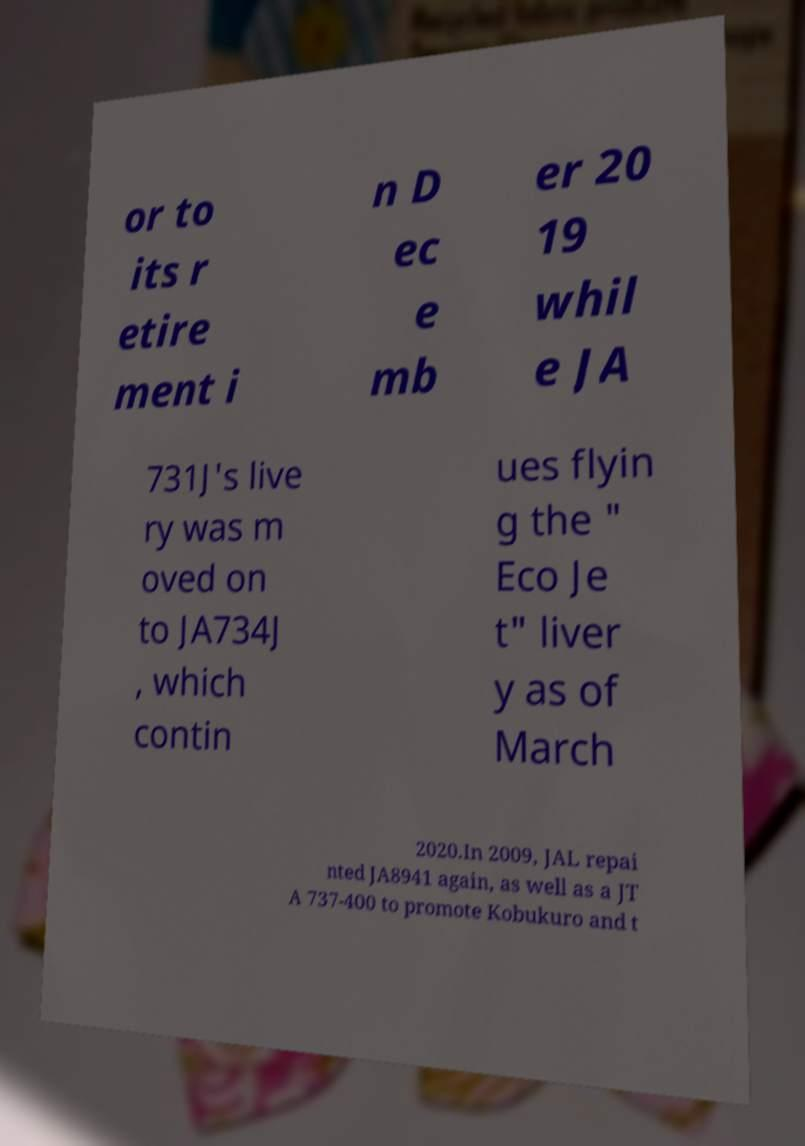There's text embedded in this image that I need extracted. Can you transcribe it verbatim? or to its r etire ment i n D ec e mb er 20 19 whil e JA 731J's live ry was m oved on to JA734J , which contin ues flyin g the " Eco Je t" liver y as of March 2020.In 2009, JAL repai nted JA8941 again, as well as a JT A 737-400 to promote Kobukuro and t 